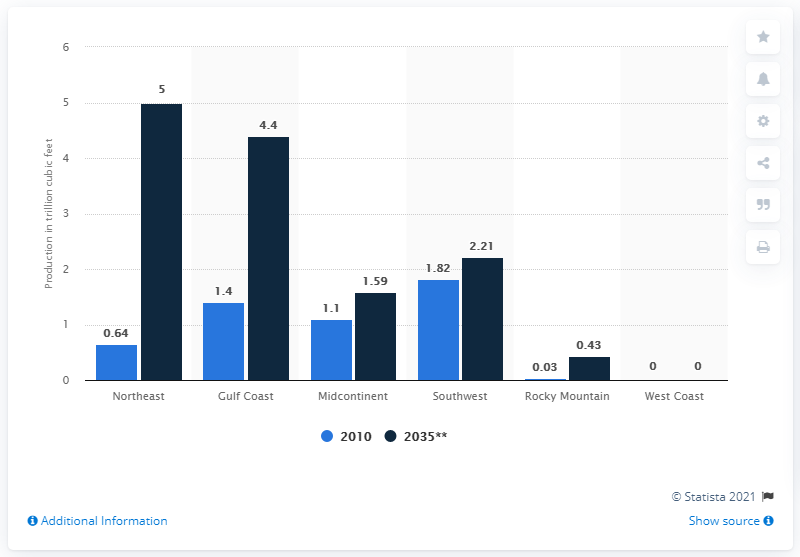List a handful of essential elements in this visual. In 2010, the Northeast produced approximately 0.64 trillion cubic feet of shale gas. In 2035, the Northeast is projected to produce approximately 0.64 million metric tons of shale gas. 